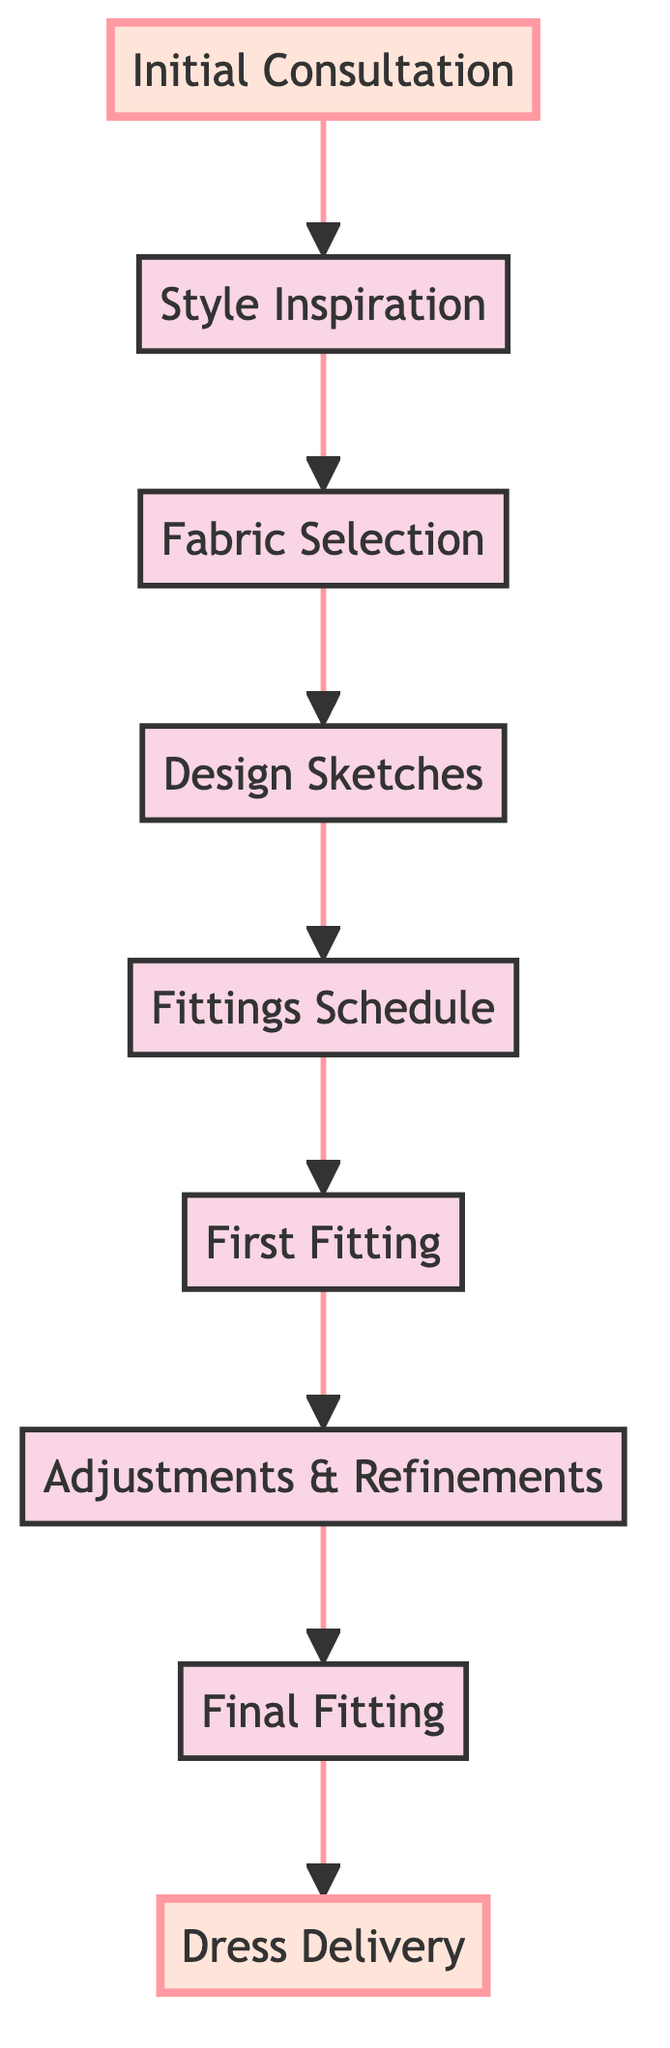What is the first step in the customer journey? The first step in the customer journey, indicated by the starting node in the diagram, is "Initial Consultation."
Answer: Initial Consultation How many steps are there in total from "Initial Consultation" to "Dress Delivery"? Counting each node from the initial step to the final step in the diagram, there are 9 steps in total.
Answer: 9 What node follows "Style Inspiration"? According to the flow in the diagram, the node that follows "Style Inspiration" is "Fabric Selection."
Answer: Fabric Selection Which step comes before "Final Fitting"? The step that precedes "Final Fitting" in the flow of the diagram is "Adjustments & Refinements."
Answer: Adjustments & Refinements What is the last step in the customer journey? The final step in the customer journey, as shown in the diagram, is "Dress Delivery."
Answer: Dress Delivery How many adjustments are made after the first fitting? The diagram states that adjustments are made specifically at the "Adjustments & Refinements" step, following the "First Fitting." Thus, only one adjustment step is indicated.
Answer: 1 What is the relationship between "Design Sketches" and "Fittings Schedule"? "Design Sketches" leads into "Fittings Schedule," indicating that the scheduling of fittings comes after design sketches are created.
Answer: Follows What is the role of "Fabric Selection" in the process? "Fabric Selection" serves the purpose of helping the bride choose fabrics that align with her vision and comfort, positioned after "Style Inspiration."
Answer: Choose fabrics Which two nodes are highlighted in the diagram? The highlighted nodes in the diagram are "Initial Consultation" and "Dress Delivery," indicating their importance in the process.
Answer: Initial Consultation, Dress Delivery 